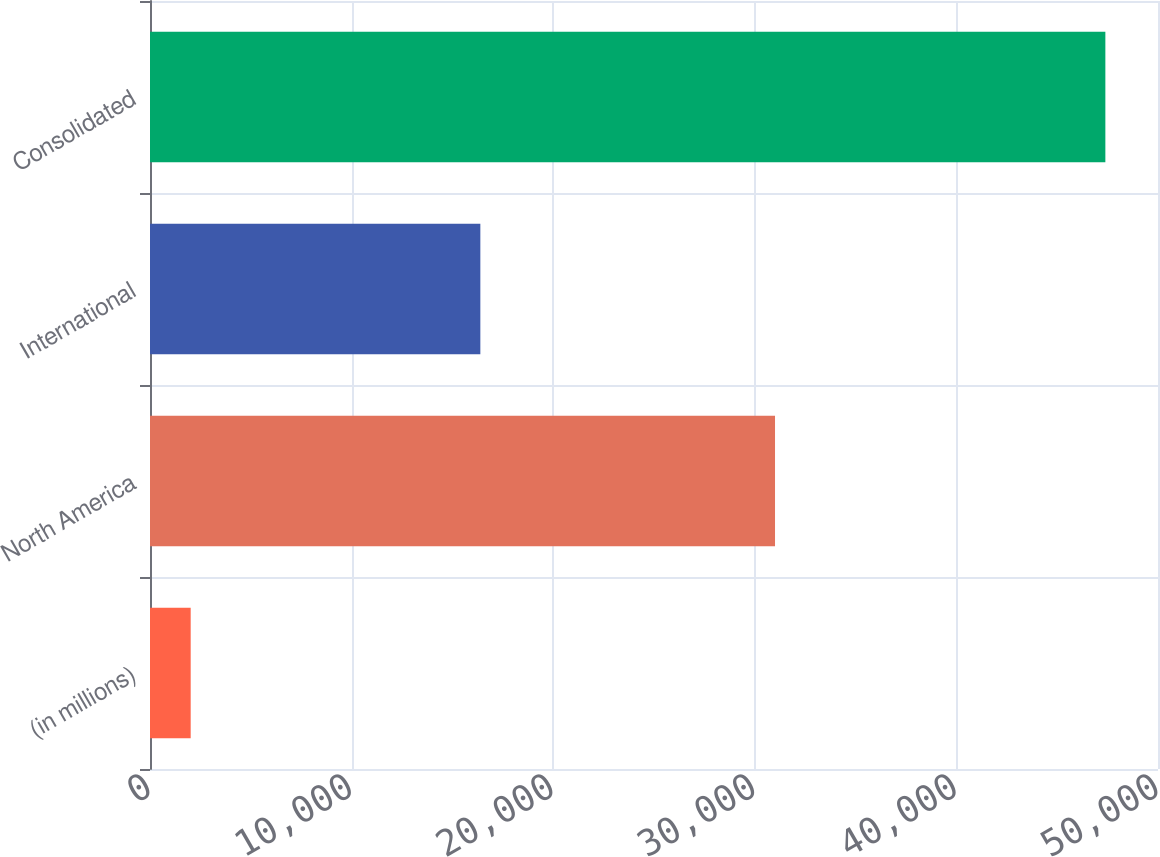Convert chart to OTSL. <chart><loc_0><loc_0><loc_500><loc_500><bar_chart><fcel>(in millions)<fcel>North America<fcel>International<fcel>Consolidated<nl><fcel>2018<fcel>31003<fcel>16386<fcel>47389<nl></chart> 